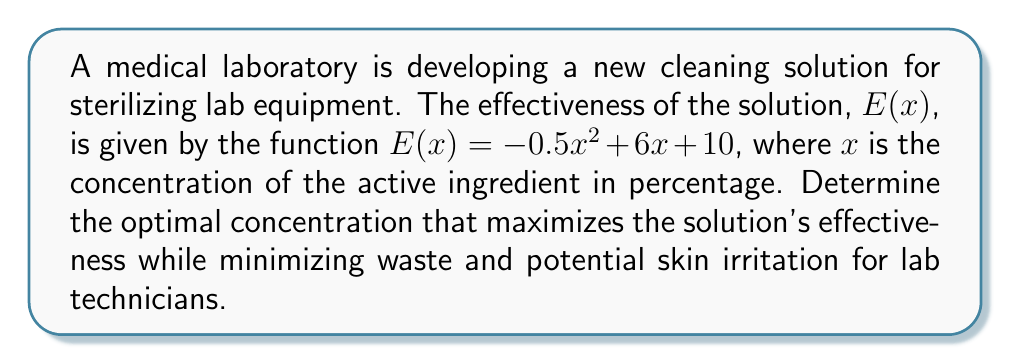Solve this math problem. To find the optimal concentration, we need to determine the maximum point of the effectiveness function E(x). This can be done using derivatives:

1. Find the first derivative of E(x):
   $E'(x) = \frac{d}{dx}(-0.5x^2 + 6x + 10)$
   $E'(x) = -x + 6$

2. Set the first derivative equal to zero to find critical points:
   $E'(x) = 0$
   $-x + 6 = 0$
   $x = 6$

3. Verify it's a maximum by checking the second derivative:
   $E''(x) = \frac{d}{dx}(-x + 6) = -1$

   Since $E''(6) = -1 < 0$, the critical point x = 6 is a maximum.

4. Therefore, the optimal concentration is 6%.

This concentration maximizes effectiveness while minimizing waste and potential skin irritation for lab technicians who prioritize comfort in their work attire.
Answer: 6% 